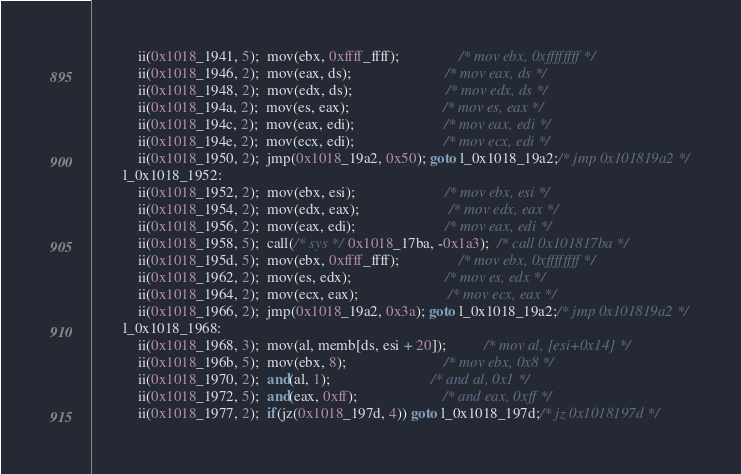Convert code to text. <code><loc_0><loc_0><loc_500><loc_500><_C#_>            ii(0x1018_1941, 5);  mov(ebx, 0xffff_ffff);                /* mov ebx, 0xffffffff */
            ii(0x1018_1946, 2);  mov(eax, ds);                         /* mov eax, ds */
            ii(0x1018_1948, 2);  mov(edx, ds);                         /* mov edx, ds */
            ii(0x1018_194a, 2);  mov(es, eax);                         /* mov es, eax */
            ii(0x1018_194c, 2);  mov(eax, edi);                        /* mov eax, edi */
            ii(0x1018_194e, 2);  mov(ecx, edi);                        /* mov ecx, edi */
            ii(0x1018_1950, 2);  jmp(0x1018_19a2, 0x50); goto l_0x1018_19a2;/* jmp 0x101819a2 */
        l_0x1018_1952:
            ii(0x1018_1952, 2);  mov(ebx, esi);                        /* mov ebx, esi */
            ii(0x1018_1954, 2);  mov(edx, eax);                        /* mov edx, eax */
            ii(0x1018_1956, 2);  mov(eax, edi);                        /* mov eax, edi */
            ii(0x1018_1958, 5);  call(/* sys */ 0x1018_17ba, -0x1a3);  /* call 0x101817ba */
            ii(0x1018_195d, 5);  mov(ebx, 0xffff_ffff);                /* mov ebx, 0xffffffff */
            ii(0x1018_1962, 2);  mov(es, edx);                         /* mov es, edx */
            ii(0x1018_1964, 2);  mov(ecx, eax);                        /* mov ecx, eax */
            ii(0x1018_1966, 2);  jmp(0x1018_19a2, 0x3a); goto l_0x1018_19a2;/* jmp 0x101819a2 */
        l_0x1018_1968:
            ii(0x1018_1968, 3);  mov(al, memb[ds, esi + 20]);          /* mov al, [esi+0x14] */
            ii(0x1018_196b, 5);  mov(ebx, 8);                          /* mov ebx, 0x8 */
            ii(0x1018_1970, 2);  and(al, 1);                           /* and al, 0x1 */
            ii(0x1018_1972, 5);  and(eax, 0xff);                       /* and eax, 0xff */
            ii(0x1018_1977, 2);  if(jz(0x1018_197d, 4)) goto l_0x1018_197d;/* jz 0x1018197d */</code> 